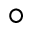<formula> <loc_0><loc_0><loc_500><loc_500>^ { \circ }</formula> 